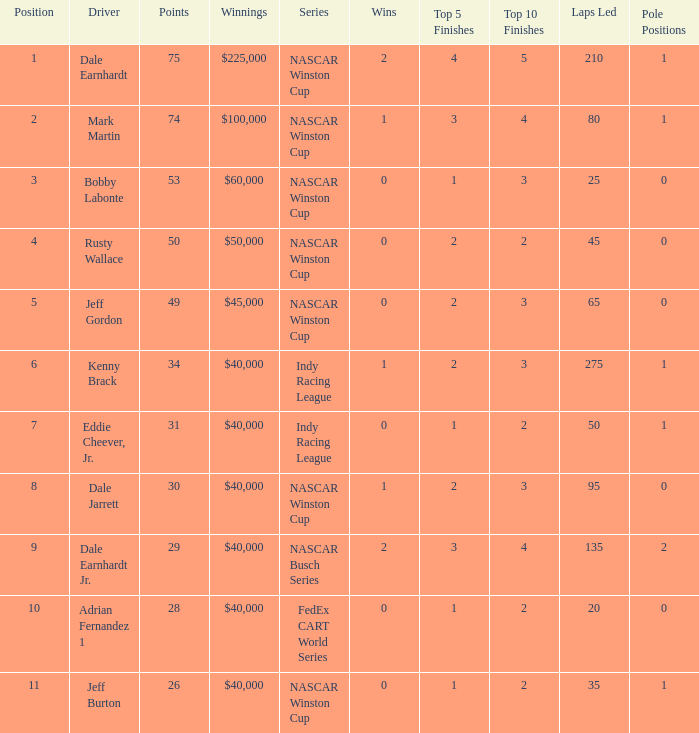In what series did Bobby Labonte drive? NASCAR Winston Cup. 